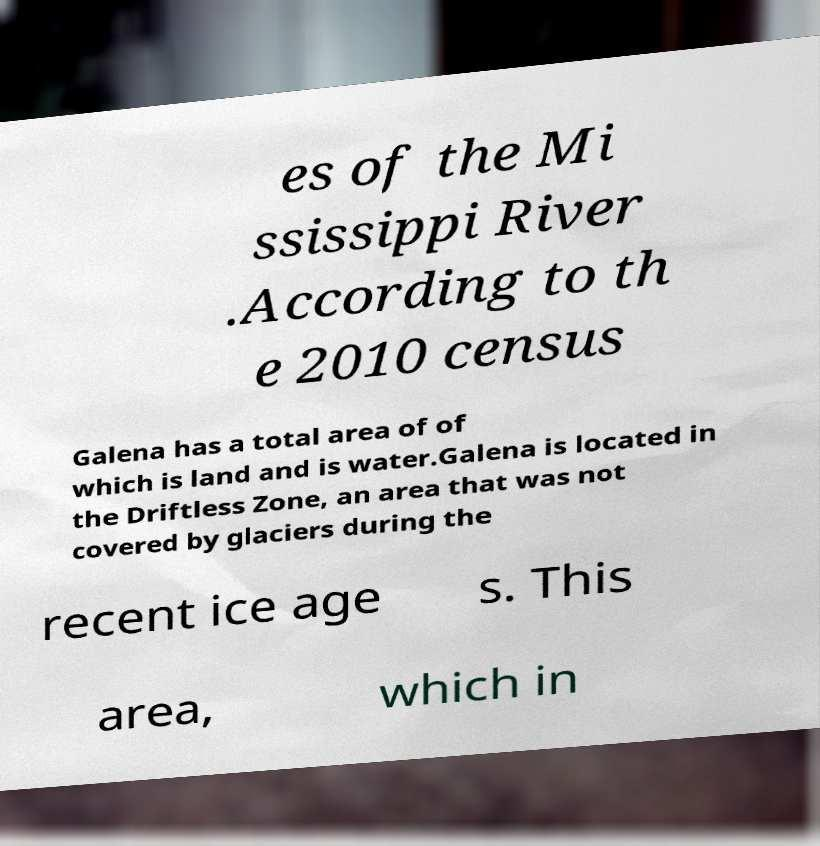Can you accurately transcribe the text from the provided image for me? es of the Mi ssissippi River .According to th e 2010 census Galena has a total area of of which is land and is water.Galena is located in the Driftless Zone, an area that was not covered by glaciers during the recent ice age s. This area, which in 